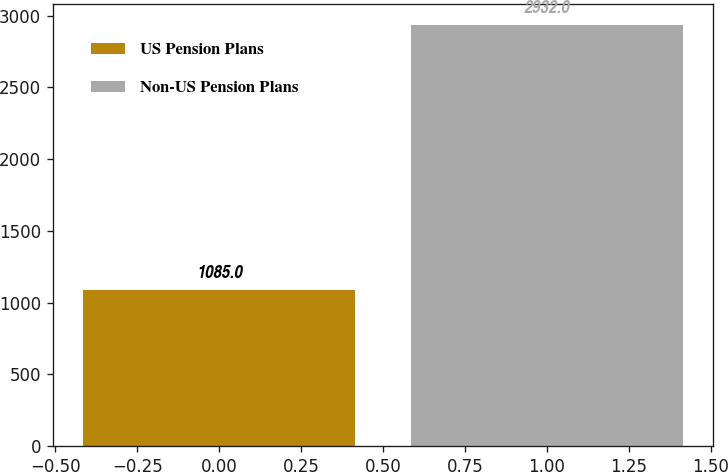<chart> <loc_0><loc_0><loc_500><loc_500><bar_chart><fcel>US Pension Plans<fcel>Non-US Pension Plans<nl><fcel>1085<fcel>2932<nl></chart> 